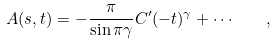<formula> <loc_0><loc_0><loc_500><loc_500>A ( s , t ) = - \frac { \pi } { \sin \pi \gamma } C ^ { \prime } ( - t ) ^ { \gamma } + \cdots \quad ,</formula> 